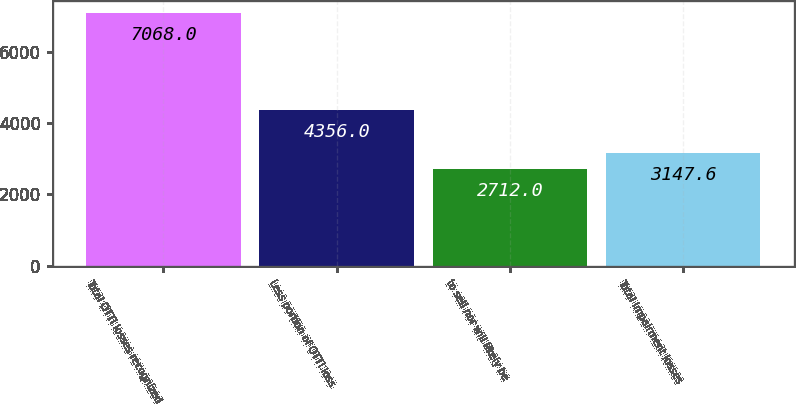<chart> <loc_0><loc_0><loc_500><loc_500><bar_chart><fcel>Total OTTI losses recognized<fcel>Less portion of OTTI loss<fcel>to sell nor will likely be<fcel>Total impairment losses<nl><fcel>7068<fcel>4356<fcel>2712<fcel>3147.6<nl></chart> 